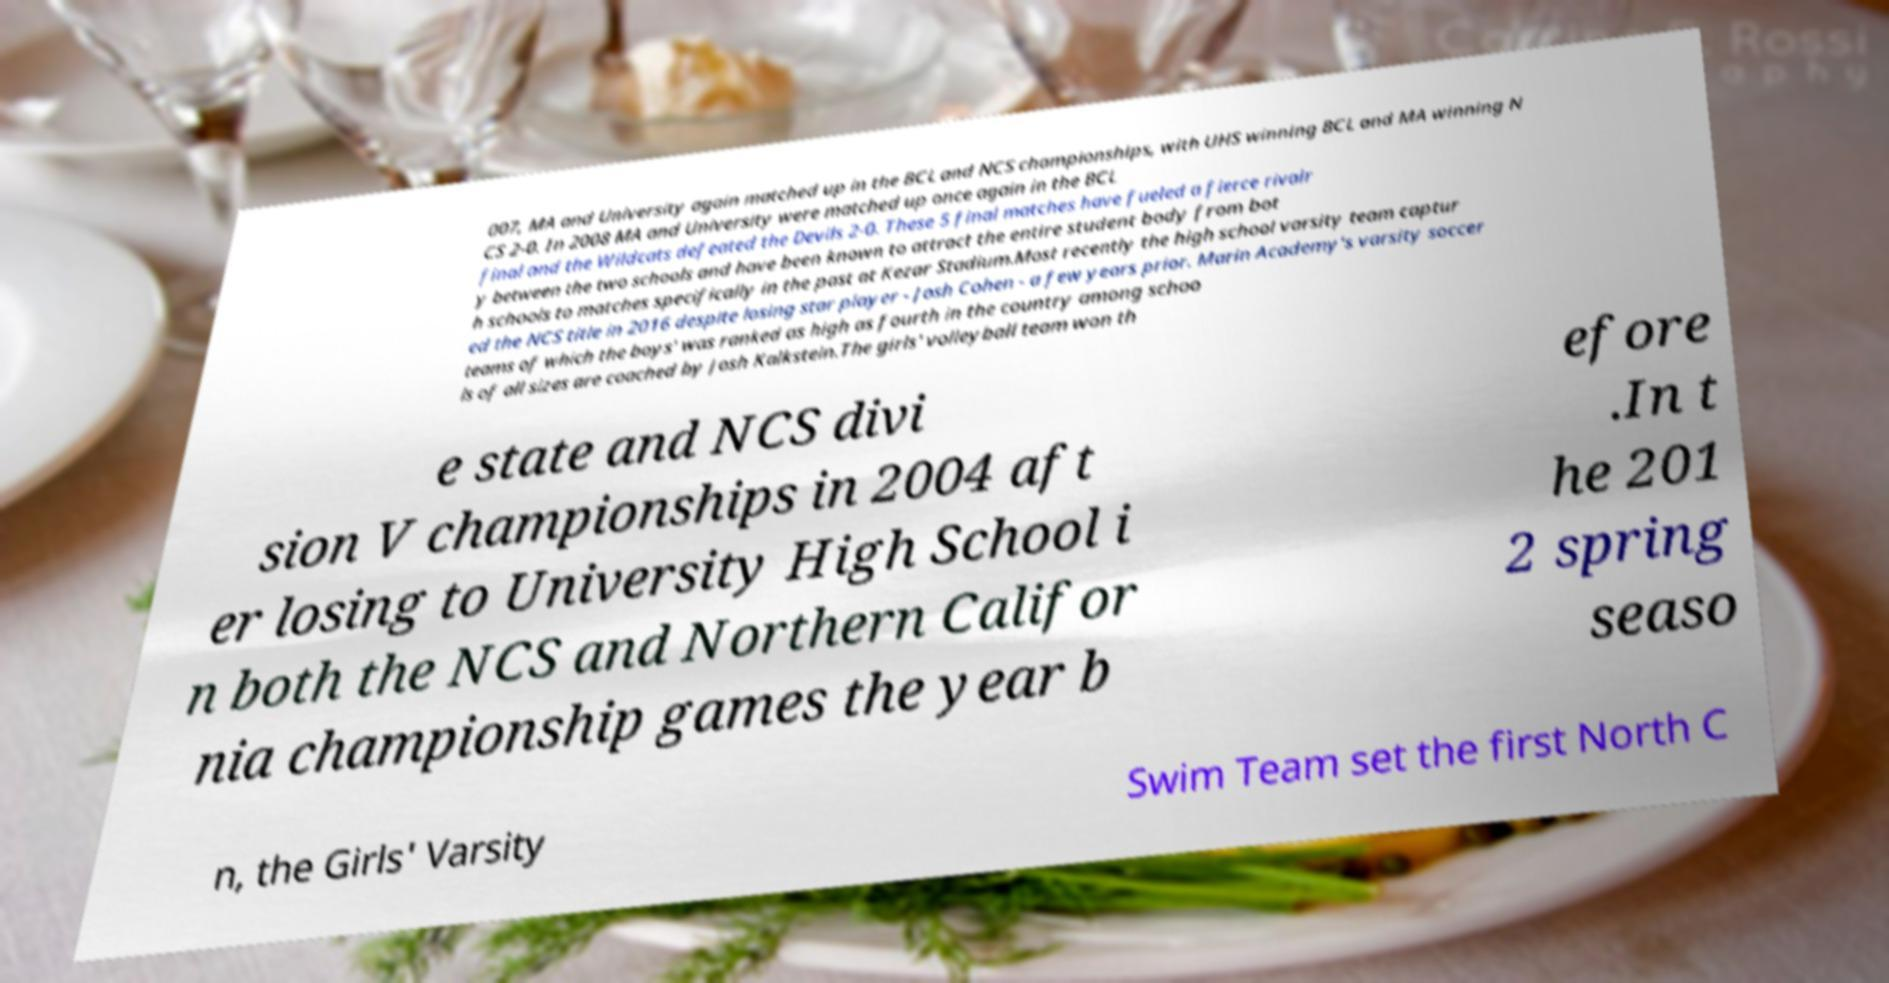Could you extract and type out the text from this image? 007, MA and University again matched up in the BCL and NCS championships, with UHS winning BCL and MA winning N CS 2-0. In 2008 MA and University were matched up once again in the BCL final and the Wildcats defeated the Devils 2-0. These 5 final matches have fueled a fierce rivalr y between the two schools and have been known to attract the entire student body from bot h schools to matches specifically in the past at Kezar Stadium.Most recently the high school varsity team captur ed the NCS title in 2016 despite losing star player - Josh Cohen - a few years prior. Marin Academy's varsity soccer teams of which the boys' was ranked as high as fourth in the country among schoo ls of all sizes are coached by Josh Kalkstein.The girls' volleyball team won th e state and NCS divi sion V championships in 2004 aft er losing to University High School i n both the NCS and Northern Califor nia championship games the year b efore .In t he 201 2 spring seaso n, the Girls' Varsity Swim Team set the first North C 